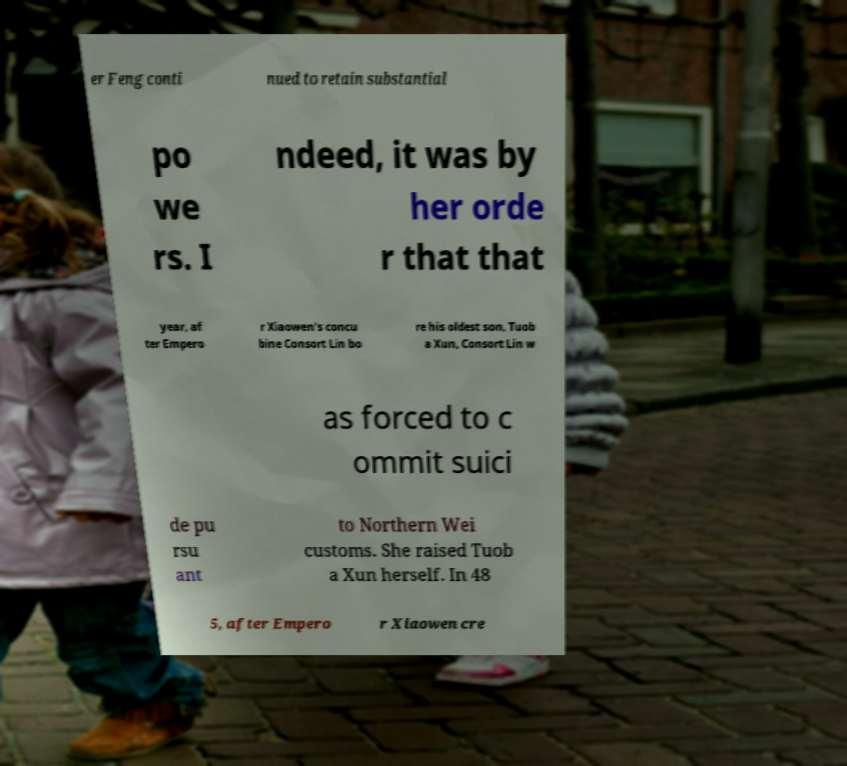I need the written content from this picture converted into text. Can you do that? er Feng conti nued to retain substantial po we rs. I ndeed, it was by her orde r that that year, af ter Empero r Xiaowen's concu bine Consort Lin bo re his oldest son, Tuob a Xun, Consort Lin w as forced to c ommit suici de pu rsu ant to Northern Wei customs. She raised Tuob a Xun herself. In 48 5, after Empero r Xiaowen cre 